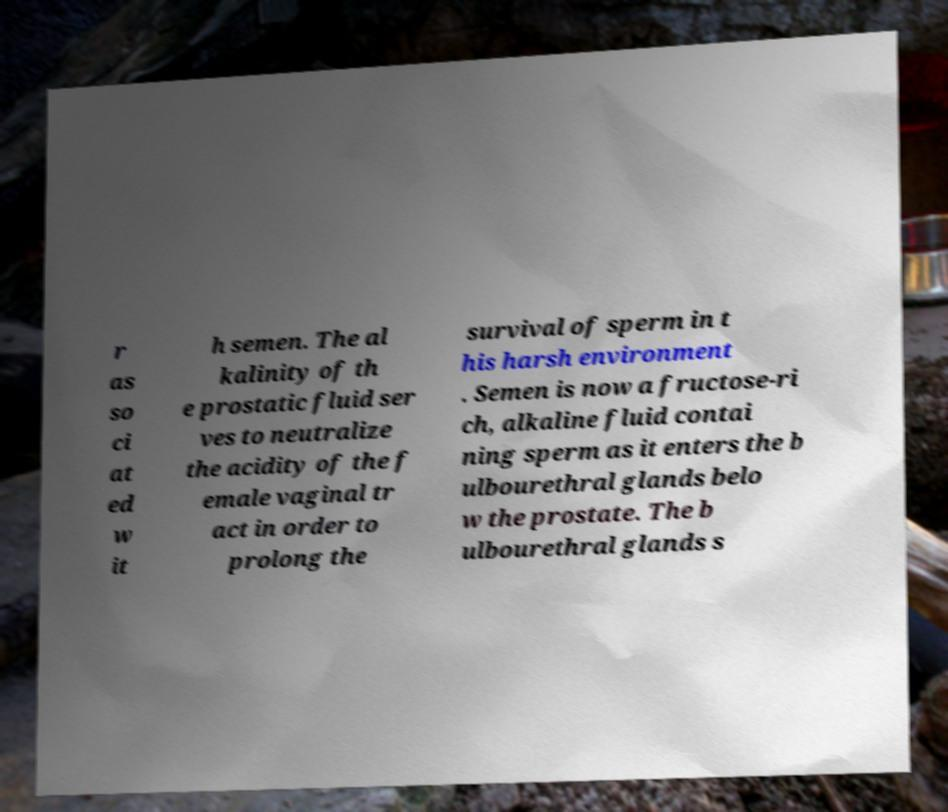Could you assist in decoding the text presented in this image and type it out clearly? r as so ci at ed w it h semen. The al kalinity of th e prostatic fluid ser ves to neutralize the acidity of the f emale vaginal tr act in order to prolong the survival of sperm in t his harsh environment . Semen is now a fructose-ri ch, alkaline fluid contai ning sperm as it enters the b ulbourethral glands belo w the prostate. The b ulbourethral glands s 